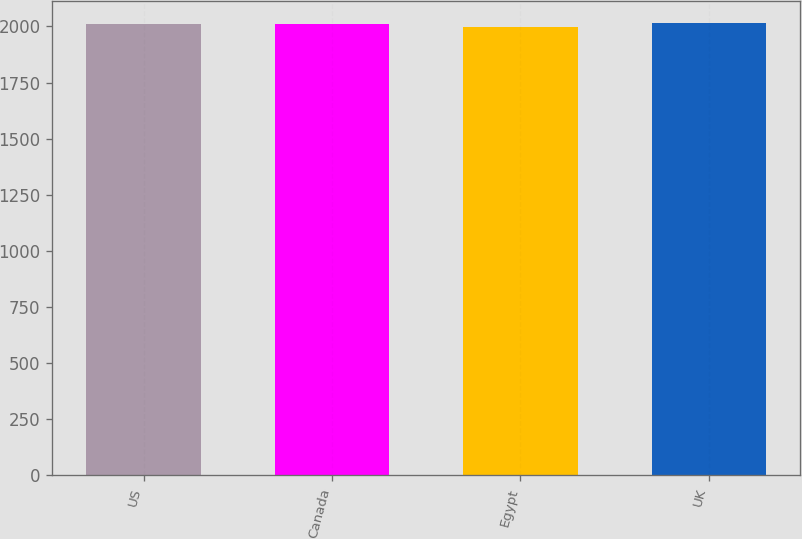<chart> <loc_0><loc_0><loc_500><loc_500><bar_chart><fcel>US<fcel>Canada<fcel>Egypt<fcel>UK<nl><fcel>2011<fcel>2012.5<fcel>1998<fcel>2014<nl></chart> 